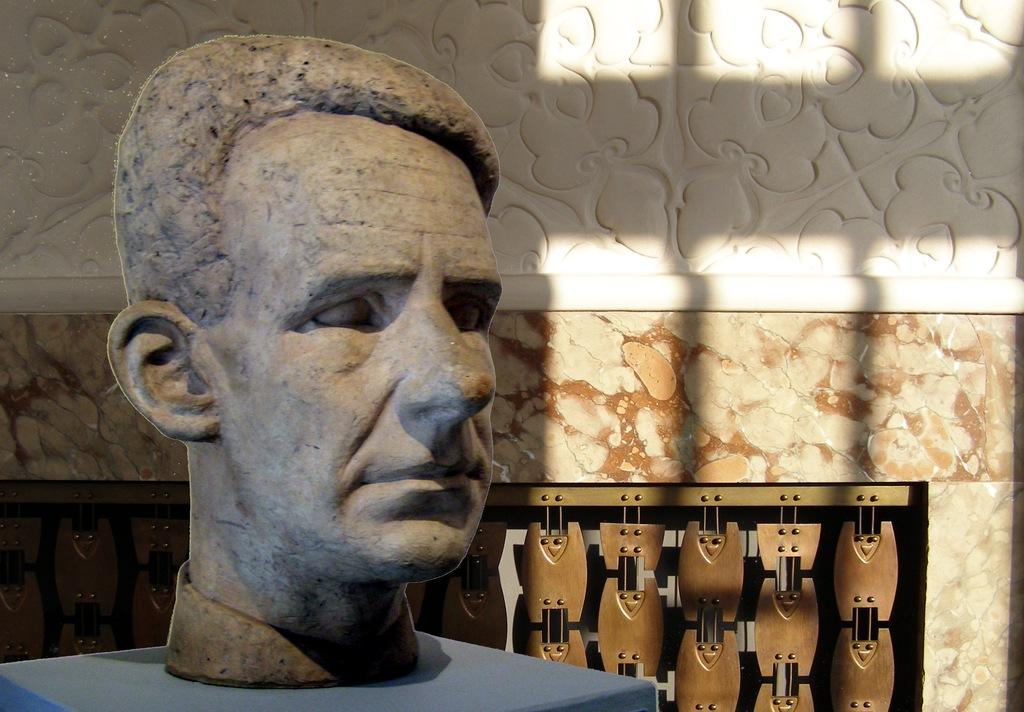What is the main subject of the image? There is a statue of a person in the image. What is the statue standing on? The statue is on a blue surface. What color is the wall in the image? The wall in the image is white and cream colored. What type of object can be seen on or near the wall? There is a brown object on or near the wall. How does the statue contribute to the betterment of society in the image? The image does not provide any information about the statue's impact on society, so we cannot determine its contribution. 